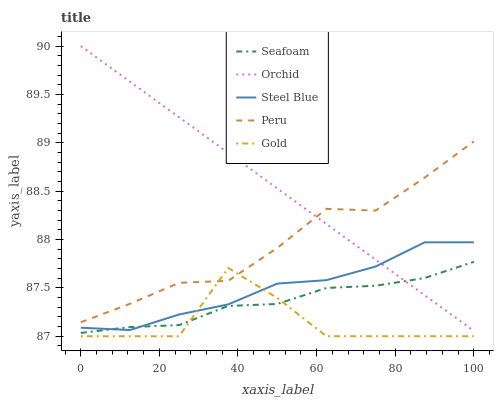Does Steel Blue have the minimum area under the curve?
Answer yes or no. No. Does Steel Blue have the maximum area under the curve?
Answer yes or no. No. Is Steel Blue the smoothest?
Answer yes or no. No. Is Steel Blue the roughest?
Answer yes or no. No. Does Steel Blue have the lowest value?
Answer yes or no. No. Does Steel Blue have the highest value?
Answer yes or no. No. Is Steel Blue less than Peru?
Answer yes or no. Yes. Is Peru greater than Seafoam?
Answer yes or no. Yes. Does Steel Blue intersect Peru?
Answer yes or no. No. 